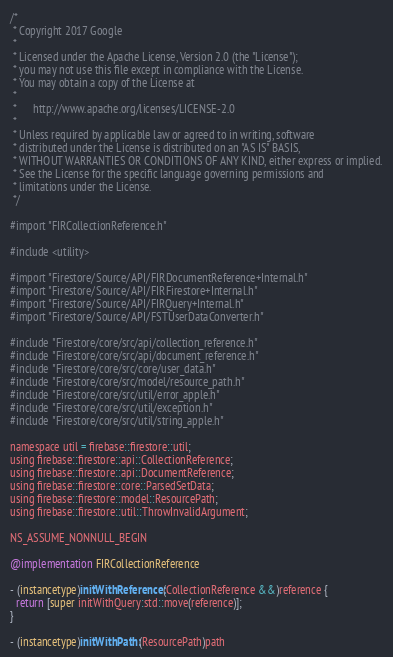Convert code to text. <code><loc_0><loc_0><loc_500><loc_500><_ObjectiveC_>/*
 * Copyright 2017 Google
 *
 * Licensed under the Apache License, Version 2.0 (the "License");
 * you may not use this file except in compliance with the License.
 * You may obtain a copy of the License at
 *
 *      http://www.apache.org/licenses/LICENSE-2.0
 *
 * Unless required by applicable law or agreed to in writing, software
 * distributed under the License is distributed on an "AS IS" BASIS,
 * WITHOUT WARRANTIES OR CONDITIONS OF ANY KIND, either express or implied.
 * See the License for the specific language governing permissions and
 * limitations under the License.
 */

#import "FIRCollectionReference.h"

#include <utility>

#import "Firestore/Source/API/FIRDocumentReference+Internal.h"
#import "Firestore/Source/API/FIRFirestore+Internal.h"
#import "Firestore/Source/API/FIRQuery+Internal.h"
#import "Firestore/Source/API/FSTUserDataConverter.h"

#include "Firestore/core/src/api/collection_reference.h"
#include "Firestore/core/src/api/document_reference.h"
#include "Firestore/core/src/core/user_data.h"
#include "Firestore/core/src/model/resource_path.h"
#include "Firestore/core/src/util/error_apple.h"
#include "Firestore/core/src/util/exception.h"
#include "Firestore/core/src/util/string_apple.h"

namespace util = firebase::firestore::util;
using firebase::firestore::api::CollectionReference;
using firebase::firestore::api::DocumentReference;
using firebase::firestore::core::ParsedSetData;
using firebase::firestore::model::ResourcePath;
using firebase::firestore::util::ThrowInvalidArgument;

NS_ASSUME_NONNULL_BEGIN

@implementation FIRCollectionReference

- (instancetype)initWithReference:(CollectionReference &&)reference {
  return [super initWithQuery:std::move(reference)];
}

- (instancetype)initWithPath:(ResourcePath)path</code> 